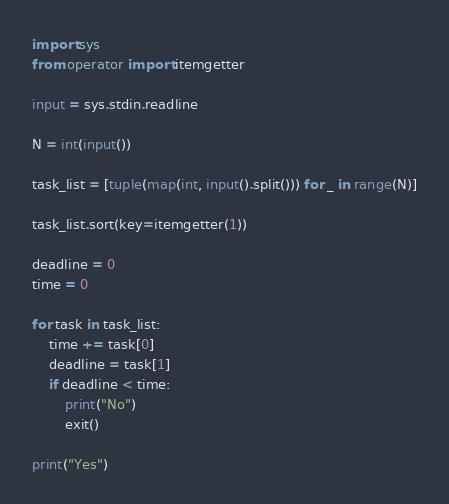Convert code to text. <code><loc_0><loc_0><loc_500><loc_500><_Python_>import sys
from operator import itemgetter

input = sys.stdin.readline

N = int(input())

task_list = [tuple(map(int, input().split())) for _ in range(N)]

task_list.sort(key=itemgetter(1))

deadline = 0
time = 0

for task in task_list:
    time += task[0]
    deadline = task[1]
    if deadline < time:
        print("No")
        exit()

print("Yes")</code> 